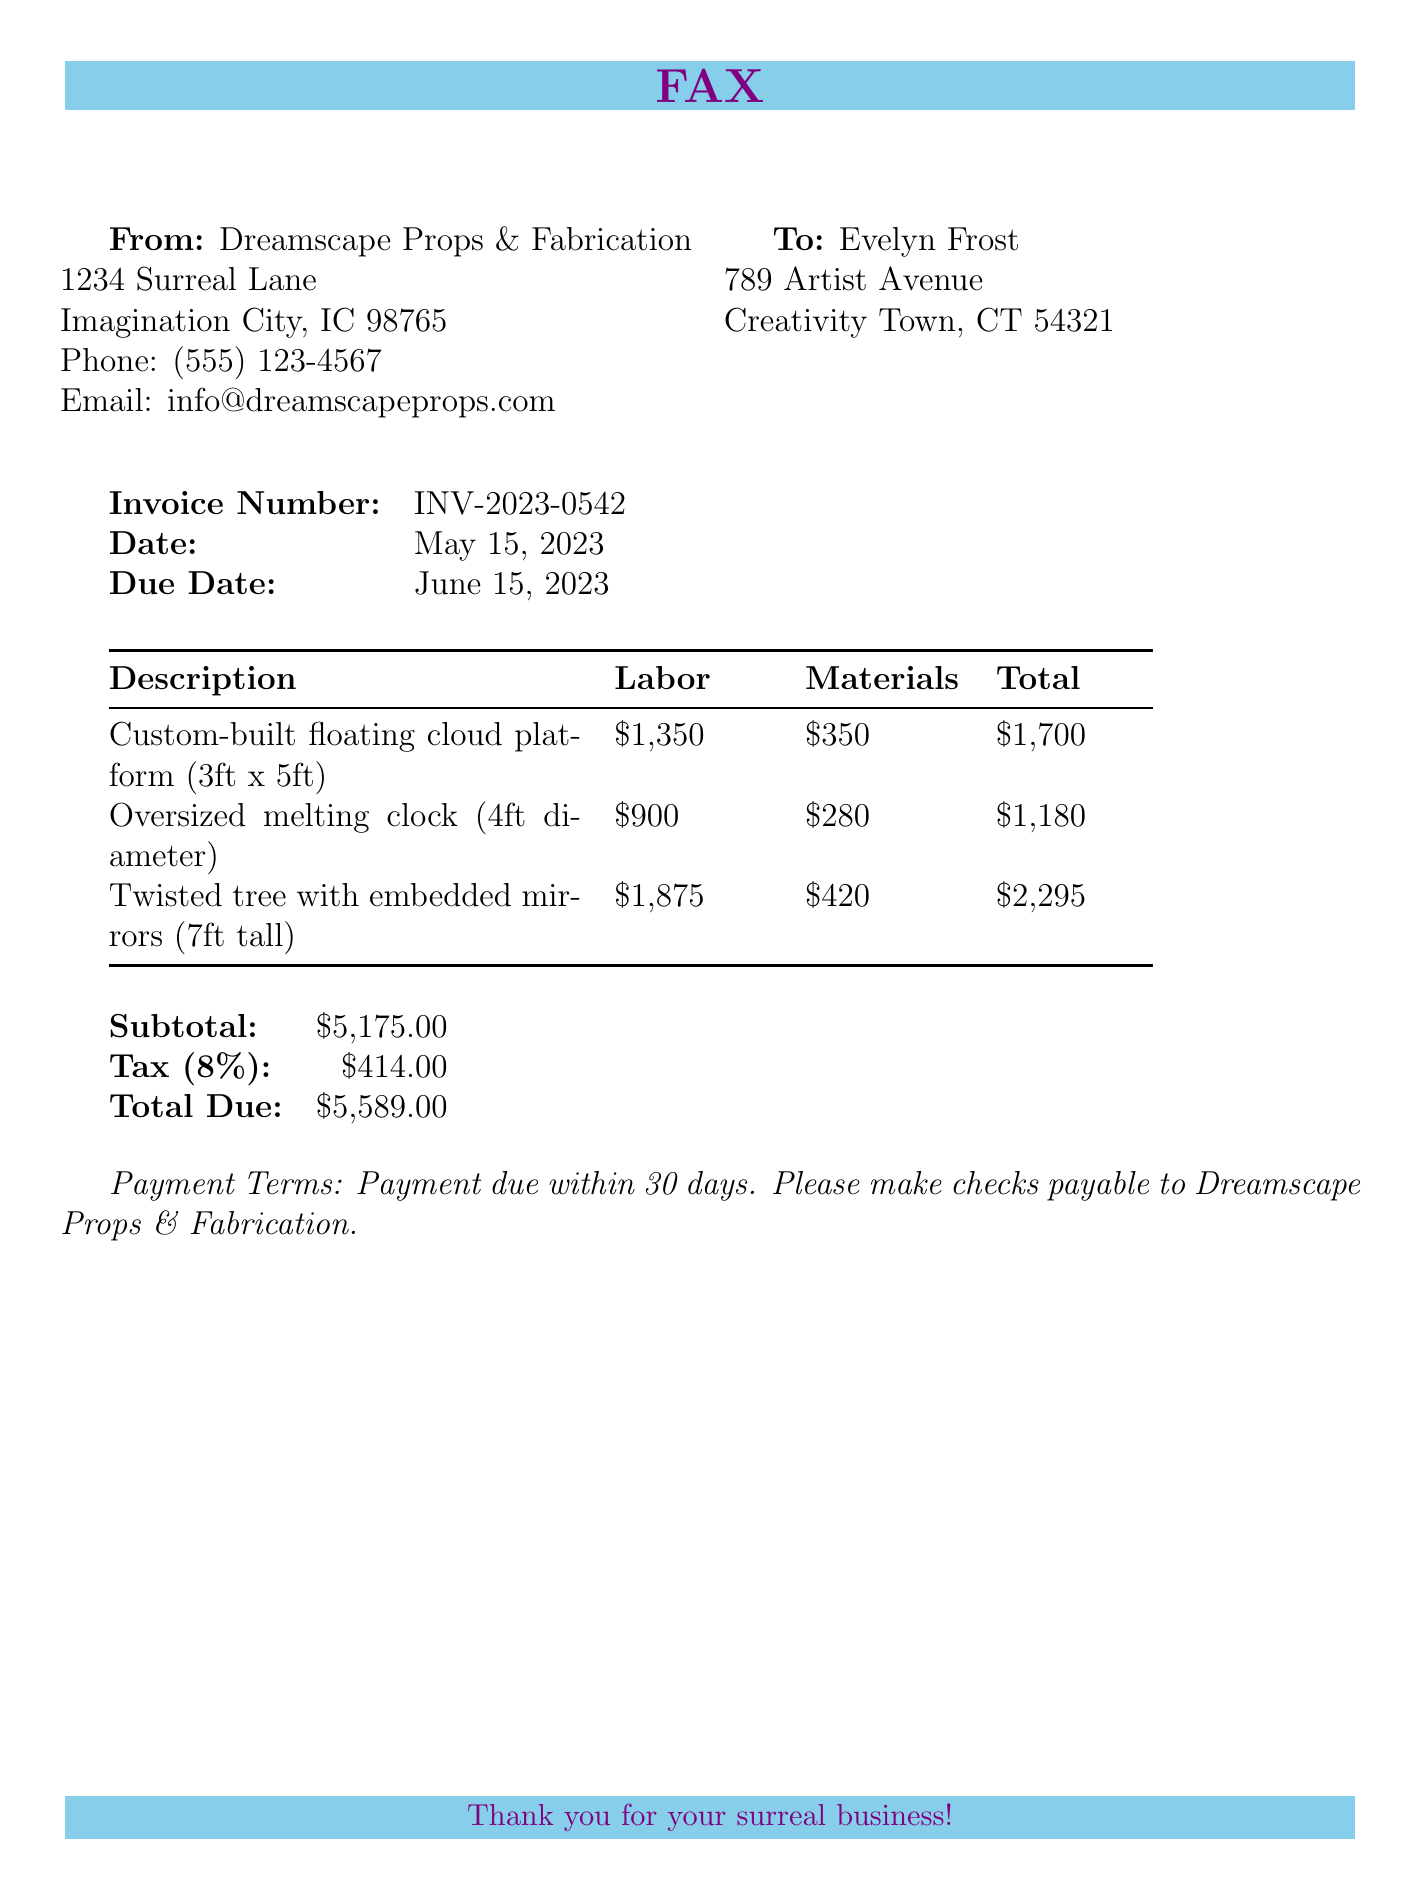what is the invoice number? The invoice number is specified in the document as INV-2023-0542.
Answer: INV-2023-0542 what is the total due amount? The total due amount is provided at the bottom of the invoice as $5,589.00.
Answer: $5,589.00 what is the due date for the invoice? The due date is stated in the document as June 15, 2023.
Answer: June 15, 2023 how much was spent on materials for the twisted tree? The document specifies the materials cost for the twisted tree with embedded mirrors as $420.
Answer: $420 what is the labor cost for the oversized melting clock? The labor cost for the oversized melting clock is mentioned as $900.
Answer: $900 how much is the tax applied on the subtotal? The document states that the tax applied is 8% of the subtotal, totaling $414.00.
Answer: $414.00 who is the sender of the fax? The sender's information is listed as Dreamscape Props & Fabrication.
Answer: Dreamscape Props & Fabrication what is the payment term specified in the document? The payment terms indicate that payment is due within 30 days.
Answer: Payment due within 30 days how many items are listed in the invoice? The invoice lists three items: a cloud platform, a melting clock, and a twisted tree.
Answer: Three items 